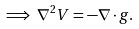<formula> <loc_0><loc_0><loc_500><loc_500>\implies \nabla ^ { 2 } V = - \nabla \cdot g .</formula> 